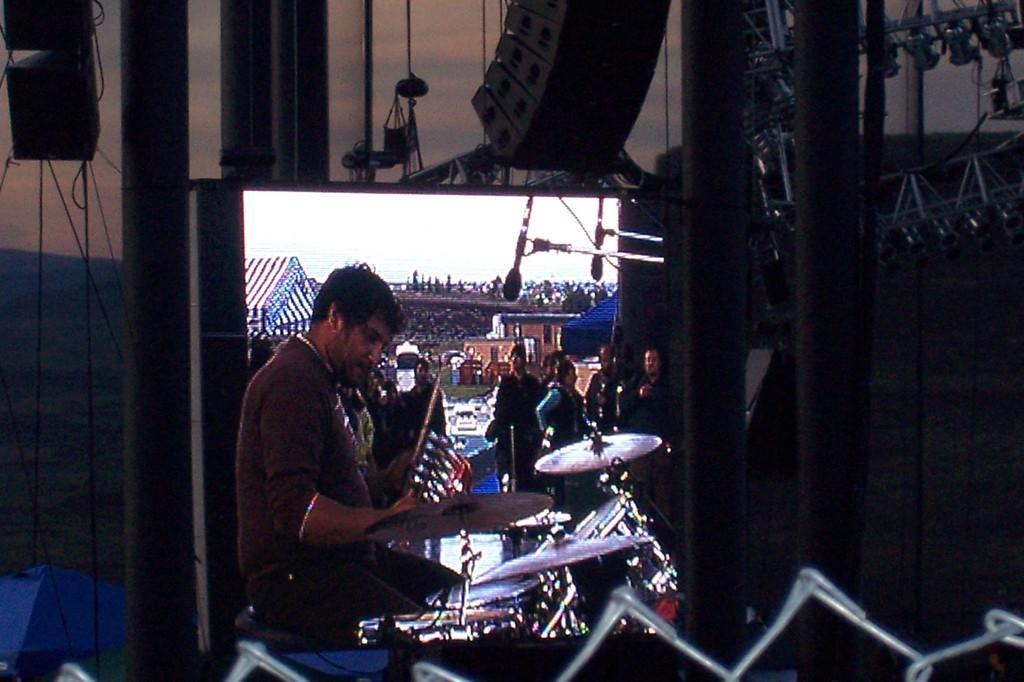Can you describe this image briefly? In the image in the center, we can see one person standing and holding musical instruments. In front of him, we can see few musical instruments. In the background, we can see the sky, clouds, tents, buildings, poles, few people are standing and few other objects. 